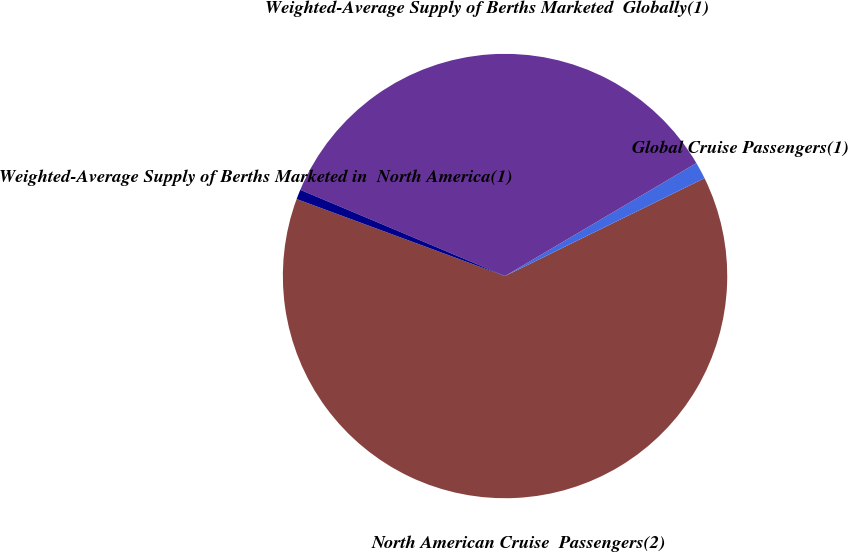Convert chart. <chart><loc_0><loc_0><loc_500><loc_500><pie_chart><fcel>North American Cruise  Passengers(2)<fcel>Global Cruise Passengers(1)<fcel>Weighted-Average Supply of Berths Marketed  Globally(1)<fcel>Weighted-Average Supply of Berths Marketed in  North America(1)<nl><fcel>62.89%<fcel>1.23%<fcel>35.17%<fcel>0.71%<nl></chart> 